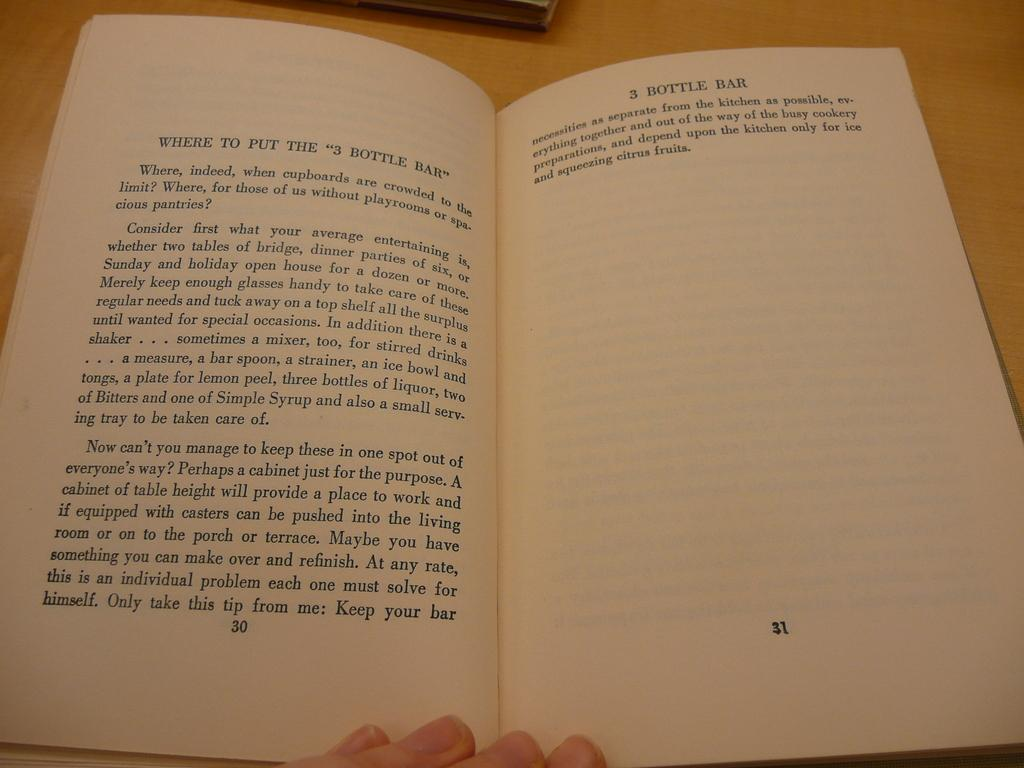<image>
Create a compact narrative representing the image presented. A book wondering where to put the 3 dollar bar 